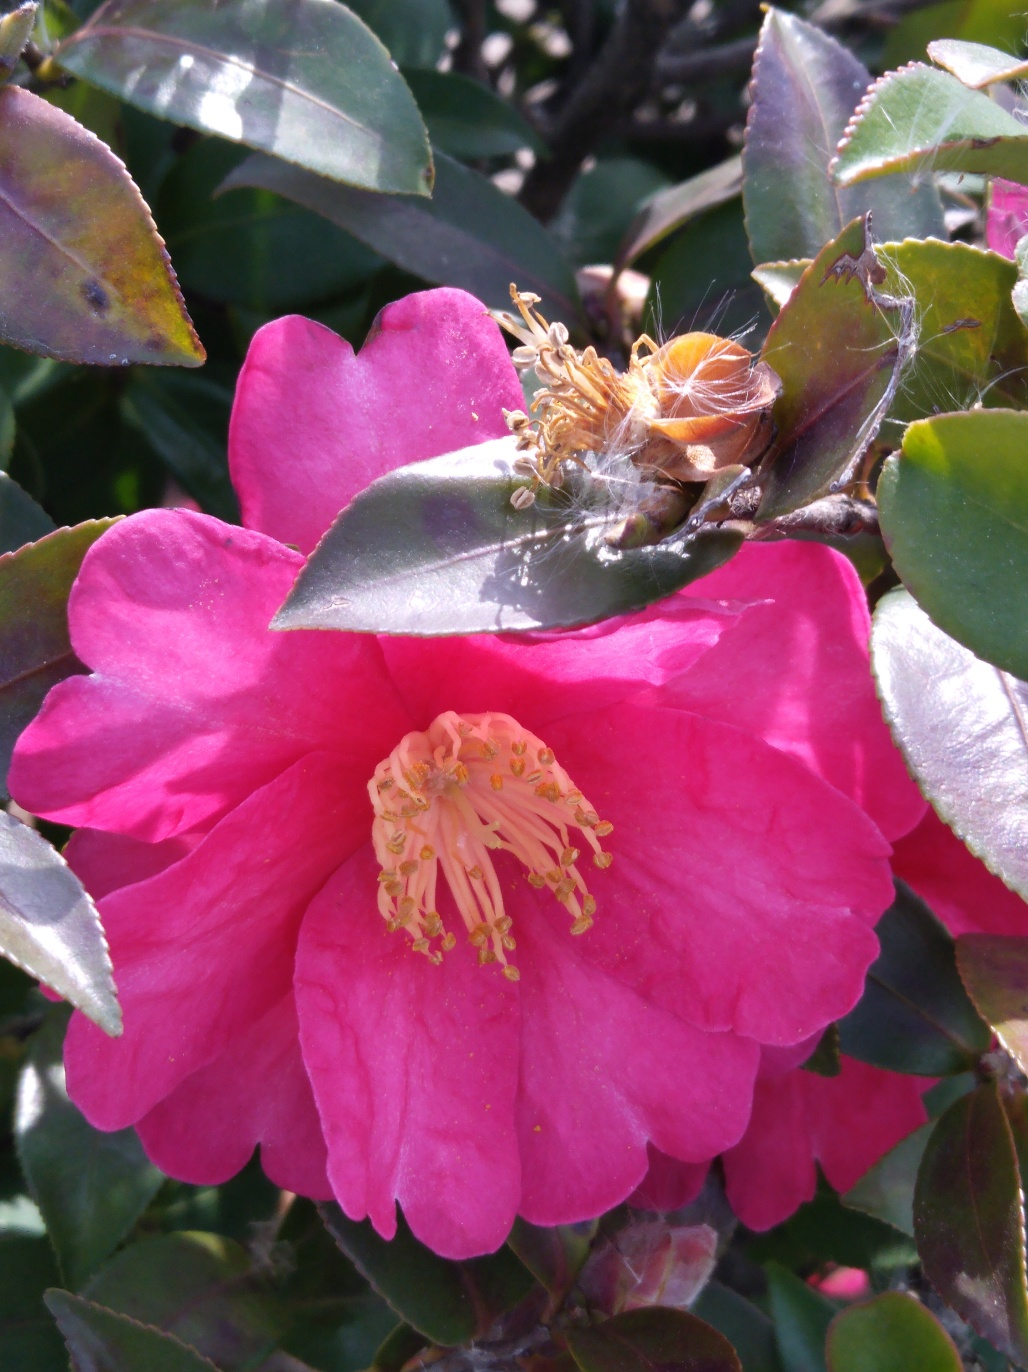Are some spider webs well presented? Based on the image, the presence of spider webs on the flower indicates that spiders have found a suitable environment here. The webs, while not the main focus, do contribute to the intricate natural aesthetic of the scene. 